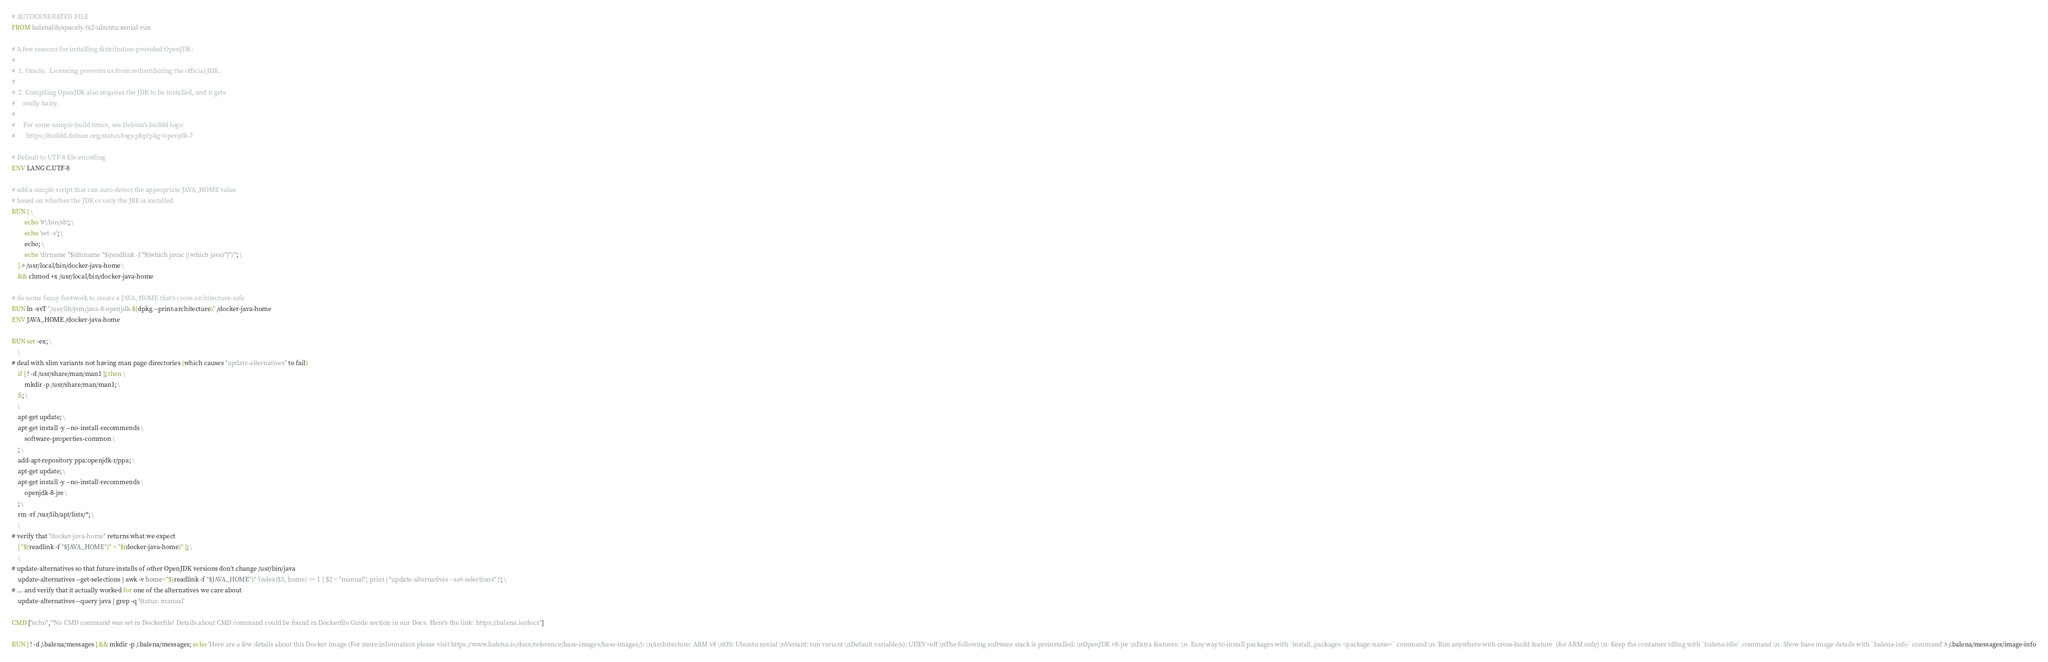<code> <loc_0><loc_0><loc_500><loc_500><_Dockerfile_># AUTOGENERATED FILE
FROM balenalib/spacely-tx2-ubuntu:xenial-run

# A few reasons for installing distribution-provided OpenJDK:
#
#  1. Oracle.  Licensing prevents us from redistributing the official JDK.
#
#  2. Compiling OpenJDK also requires the JDK to be installed, and it gets
#     really hairy.
#
#     For some sample build times, see Debian's buildd logs:
#       https://buildd.debian.org/status/logs.php?pkg=openjdk-7

# Default to UTF-8 file.encoding
ENV LANG C.UTF-8

# add a simple script that can auto-detect the appropriate JAVA_HOME value
# based on whether the JDK or only the JRE is installed
RUN { \
		echo '#!/bin/sh'; \
		echo 'set -e'; \
		echo; \
		echo 'dirname "$(dirname "$(readlink -f "$(which javac || which java)")")"'; \
	} > /usr/local/bin/docker-java-home \
	&& chmod +x /usr/local/bin/docker-java-home

# do some fancy footwork to create a JAVA_HOME that's cross-architecture-safe
RUN ln -svT "/usr/lib/jvm/java-8-openjdk-$(dpkg --print-architecture)" /docker-java-home
ENV JAVA_HOME /docker-java-home

RUN set -ex; \
	\
# deal with slim variants not having man page directories (which causes "update-alternatives" to fail)
	if [ ! -d /usr/share/man/man1 ]; then \
		mkdir -p /usr/share/man/man1; \
	fi; \
	\
	apt-get update; \
	apt-get install -y --no-install-recommends \
		software-properties-common \
	; \
	add-apt-repository ppa:openjdk-r/ppa; \
	apt-get update; \
	apt-get install -y --no-install-recommends \
		openjdk-8-jre \
	; \
	rm -rf /var/lib/apt/lists/*; \
	\
# verify that "docker-java-home" returns what we expect
	[ "$(readlink -f "$JAVA_HOME")" = "$(docker-java-home)" ]; \
	\
# update-alternatives so that future installs of other OpenJDK versions don't change /usr/bin/java
	update-alternatives --get-selections | awk -v home="$(readlink -f "$JAVA_HOME")" 'index($3, home) == 1 { $2 = "manual"; print | "update-alternatives --set-selections" }'; \
# ... and verify that it actually worked for one of the alternatives we care about
	update-alternatives --query java | grep -q 'Status: manual'

CMD ["echo","'No CMD command was set in Dockerfile! Details about CMD command could be found in Dockerfile Guide section in our Docs. Here's the link: https://balena.io/docs"]

RUN [ ! -d /.balena/messages ] && mkdir -p /.balena/messages; echo 'Here are a few details about this Docker image (For more information please visit https://www.balena.io/docs/reference/base-images/base-images/): \nArchitecture: ARM v8 \nOS: Ubuntu xenial \nVariant: run variant \nDefault variable(s): UDEV=off \nThe following software stack is preinstalled: \nOpenJDK v8-jre \nExtra features: \n- Easy way to install packages with `install_packages <package-name>` command \n- Run anywhere with cross-build feature  (for ARM only) \n- Keep the container idling with `balena-idle` command \n- Show base image details with `balena-info` command' > /.balena/messages/image-info</code> 